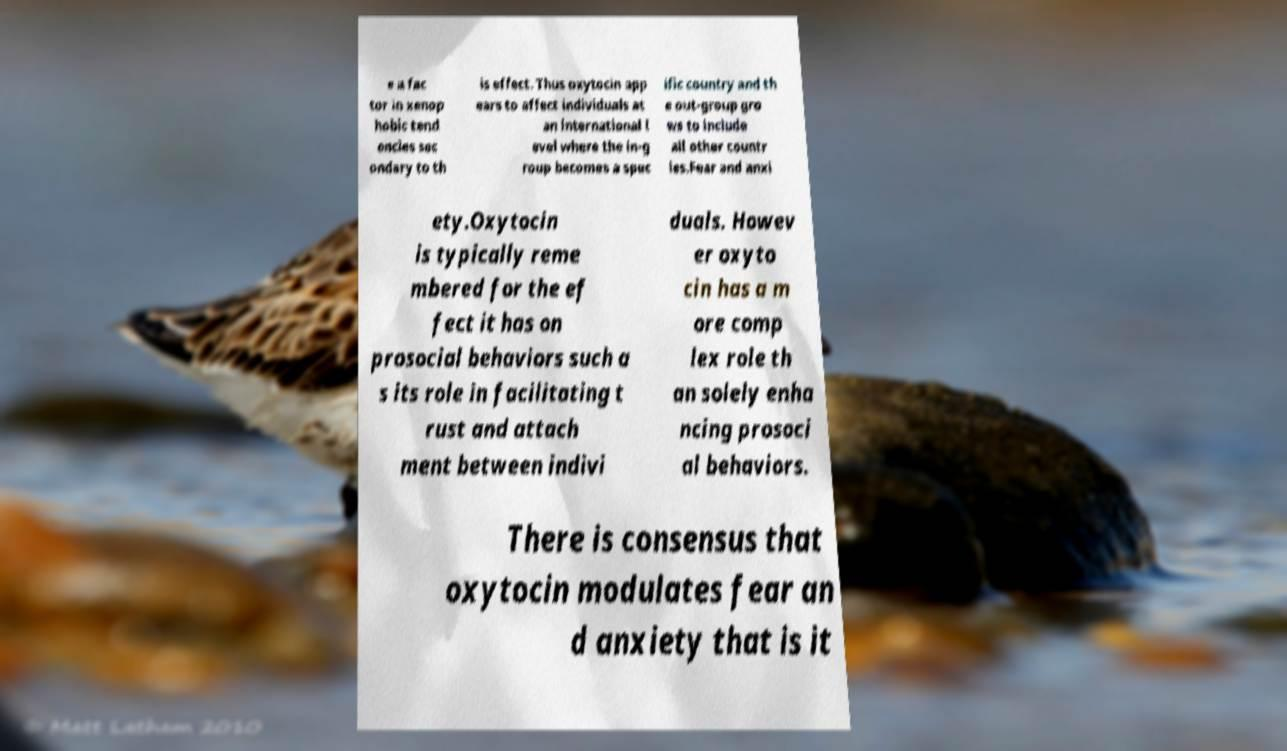Can you read and provide the text displayed in the image?This photo seems to have some interesting text. Can you extract and type it out for me? e a fac tor in xenop hobic tend encies sec ondary to th is effect. Thus oxytocin app ears to affect individuals at an international l evel where the in-g roup becomes a spec ific country and th e out-group gro ws to include all other countr ies.Fear and anxi ety.Oxytocin is typically reme mbered for the ef fect it has on prosocial behaviors such a s its role in facilitating t rust and attach ment between indivi duals. Howev er oxyto cin has a m ore comp lex role th an solely enha ncing prosoci al behaviors. There is consensus that oxytocin modulates fear an d anxiety that is it 